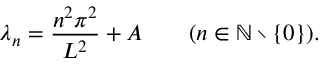Convert formula to latex. <formula><loc_0><loc_0><loc_500><loc_500>\lambda _ { n } = { \frac { n ^ { 2 } \pi ^ { 2 } } { L ^ { 2 } } } + A \quad ( n \in \mathbb { N } \ \{ 0 \} ) .</formula> 